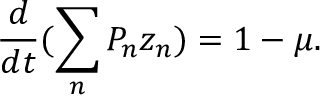Convert formula to latex. <formula><loc_0><loc_0><loc_500><loc_500>\frac { d } { d t } ( \sum _ { n } P _ { n } z _ { n } ) = 1 - \mu .</formula> 